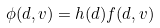<formula> <loc_0><loc_0><loc_500><loc_500>\phi ( d , v ) = h ( d ) f ( d , v )</formula> 